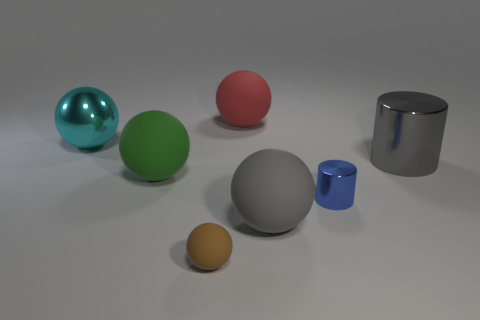Is the number of big balls on the right side of the big shiny sphere greater than the number of cyan spheres?
Offer a very short reply. Yes. Are there any rubber spheres of the same color as the small shiny cylinder?
Offer a very short reply. No. What is the color of the metallic sphere that is the same size as the red thing?
Offer a terse response. Cyan. Are there an equal number of gray cylinders and matte things?
Offer a terse response. No. How many shiny things are behind the gray thing on the right side of the tiny blue metallic cylinder?
Offer a terse response. 1. What number of things are either things that are in front of the red object or small metallic objects?
Your answer should be compact. 6. What number of large cylinders are the same material as the green sphere?
Give a very brief answer. 0. What is the shape of the large matte object that is the same color as the large metal cylinder?
Your answer should be compact. Sphere. Are there an equal number of big cyan shiny spheres in front of the large gray shiny object and big red rubber balls?
Offer a very short reply. No. What is the size of the object behind the cyan metal ball?
Your answer should be very brief. Large. 